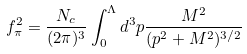Convert formula to latex. <formula><loc_0><loc_0><loc_500><loc_500>f _ { \pi } ^ { 2 } = \frac { N _ { c } } { ( 2 \pi ) ^ { 3 } } \int _ { 0 } ^ { \Lambda } d ^ { 3 } p \frac { M ^ { 2 } } { ( p ^ { 2 } + M ^ { 2 } ) ^ { 3 / 2 } }</formula> 